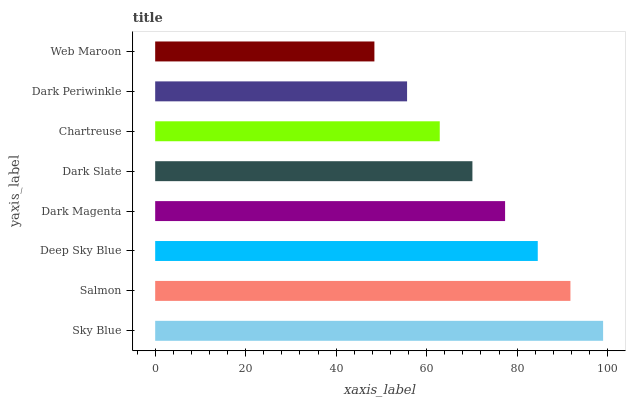Is Web Maroon the minimum?
Answer yes or no. Yes. Is Sky Blue the maximum?
Answer yes or no. Yes. Is Salmon the minimum?
Answer yes or no. No. Is Salmon the maximum?
Answer yes or no. No. Is Sky Blue greater than Salmon?
Answer yes or no. Yes. Is Salmon less than Sky Blue?
Answer yes or no. Yes. Is Salmon greater than Sky Blue?
Answer yes or no. No. Is Sky Blue less than Salmon?
Answer yes or no. No. Is Dark Magenta the high median?
Answer yes or no. Yes. Is Dark Slate the low median?
Answer yes or no. Yes. Is Dark Periwinkle the high median?
Answer yes or no. No. Is Sky Blue the low median?
Answer yes or no. No. 